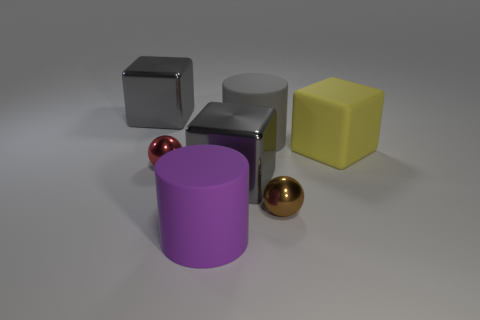Are there more red metallic objects on the left side of the yellow rubber block than big matte cylinders left of the purple rubber cylinder?
Offer a very short reply. Yes. The large cube to the right of the large gray matte object is what color?
Make the answer very short. Yellow. Are there any purple rubber objects of the same shape as the large yellow matte object?
Provide a succinct answer. No. What number of green things are rubber cubes or small metal spheres?
Make the answer very short. 0. Are there any other objects that have the same size as the red metal object?
Offer a very short reply. Yes. How many small brown things are there?
Offer a terse response. 1. What number of tiny things are either red spheres or gray blocks?
Give a very brief answer. 1. The small shiny sphere that is behind the shiny sphere that is right of the large matte cylinder that is behind the big yellow rubber object is what color?
Ensure brevity in your answer.  Red. How many other objects are there of the same color as the matte cube?
Your answer should be compact. 0. What number of shiny things are gray balls or big things?
Your response must be concise. 2. 